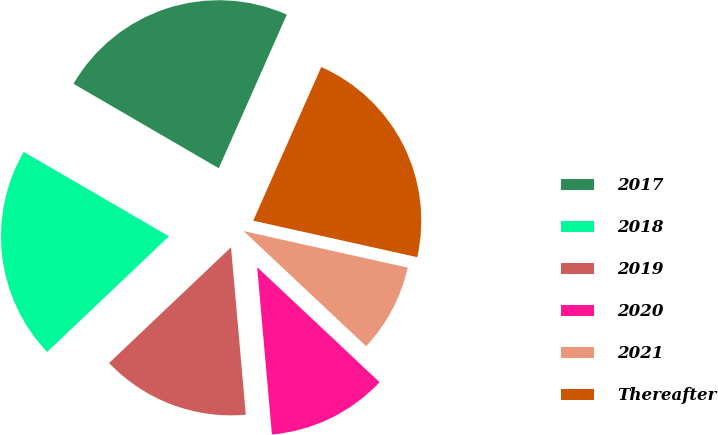<chart> <loc_0><loc_0><loc_500><loc_500><pie_chart><fcel>2017<fcel>2018<fcel>2019<fcel>2020<fcel>2021<fcel>Thereafter<nl><fcel>23.25%<fcel>20.46%<fcel>14.32%<fcel>11.59%<fcel>8.52%<fcel>21.85%<nl></chart> 